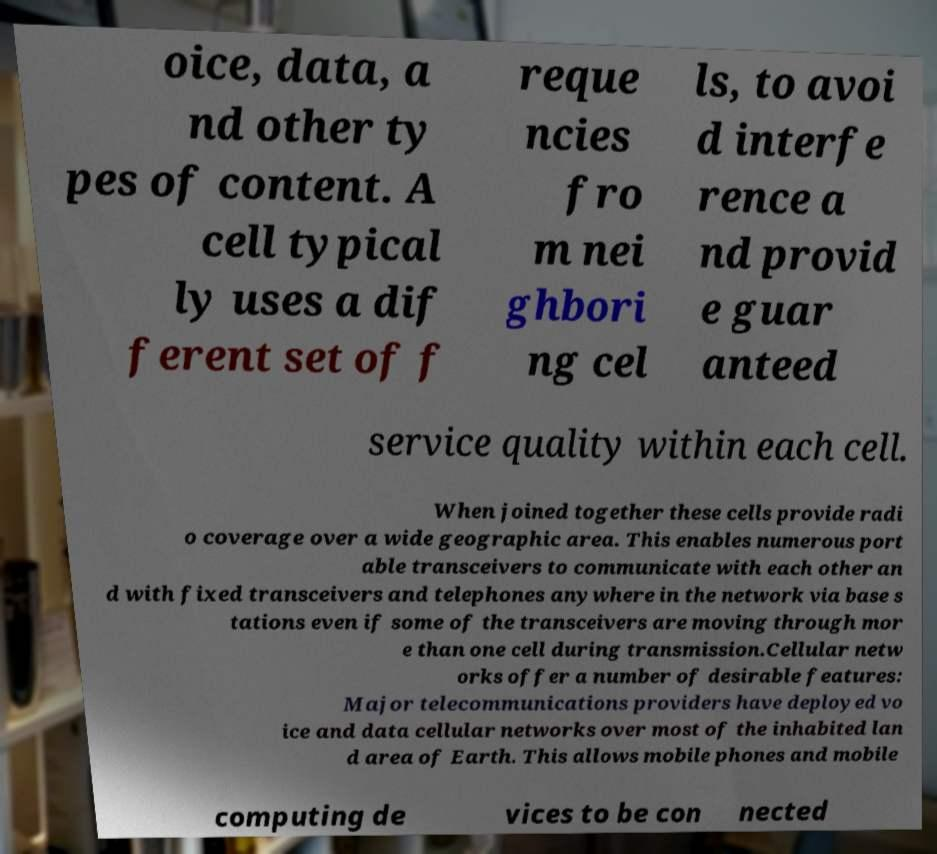For documentation purposes, I need the text within this image transcribed. Could you provide that? oice, data, a nd other ty pes of content. A cell typical ly uses a dif ferent set of f reque ncies fro m nei ghbori ng cel ls, to avoi d interfe rence a nd provid e guar anteed service quality within each cell. When joined together these cells provide radi o coverage over a wide geographic area. This enables numerous port able transceivers to communicate with each other an d with fixed transceivers and telephones anywhere in the network via base s tations even if some of the transceivers are moving through mor e than one cell during transmission.Cellular netw orks offer a number of desirable features: Major telecommunications providers have deployed vo ice and data cellular networks over most of the inhabited lan d area of Earth. This allows mobile phones and mobile computing de vices to be con nected 